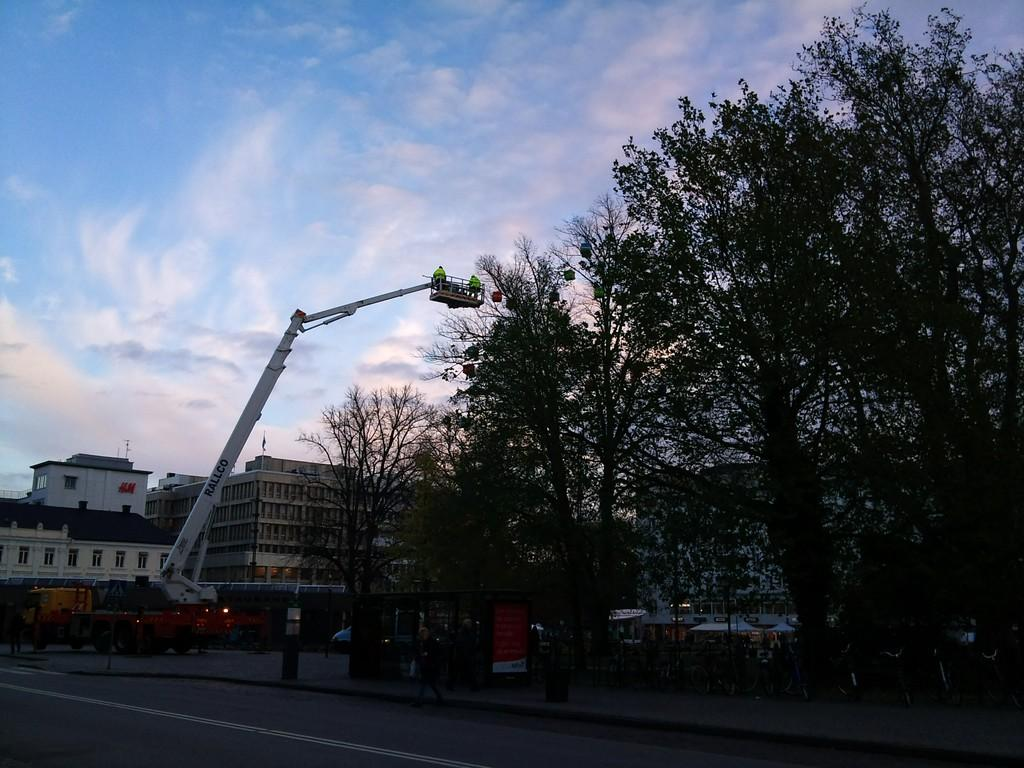What is the main feature of the image? There is a road in the image. What can be seen near the road? There are many boards near the road. What type of machinery is visible in the image? A crane is visible in the image. What else can be seen in the image besides the road and boards? Vehicles are present in the image. What natural element is present in the image? There is a tree in the image. What can be seen in the background of the image? There are buildings, clouds, and the sky visible in the background of the image. What type of cart is being pulled by the fang in the image? There is no cart or fang present in the image. 